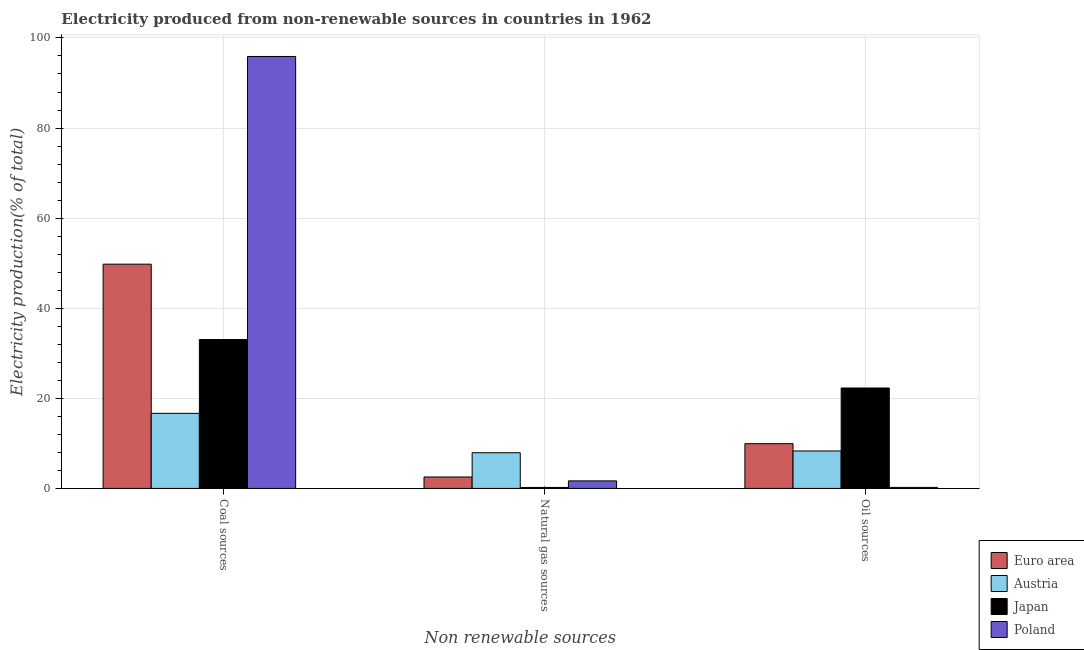How many groups of bars are there?
Your answer should be very brief. 3. Are the number of bars on each tick of the X-axis equal?
Offer a very short reply. Yes. How many bars are there on the 1st tick from the left?
Offer a very short reply. 4. What is the label of the 3rd group of bars from the left?
Your answer should be compact. Oil sources. What is the percentage of electricity produced by oil sources in Japan?
Offer a terse response. 22.29. Across all countries, what is the maximum percentage of electricity produced by natural gas?
Make the answer very short. 7.92. Across all countries, what is the minimum percentage of electricity produced by coal?
Ensure brevity in your answer.  16.66. In which country was the percentage of electricity produced by coal minimum?
Your response must be concise. Austria. What is the total percentage of electricity produced by coal in the graph?
Keep it short and to the point. 195.38. What is the difference between the percentage of electricity produced by coal in Japan and that in Poland?
Give a very brief answer. -62.84. What is the difference between the percentage of electricity produced by coal in Austria and the percentage of electricity produced by oil sources in Euro area?
Your answer should be compact. 6.73. What is the average percentage of electricity produced by natural gas per country?
Provide a succinct answer. 3.09. What is the difference between the percentage of electricity produced by natural gas and percentage of electricity produced by coal in Poland?
Your response must be concise. -94.22. In how many countries, is the percentage of electricity produced by oil sources greater than 16 %?
Offer a very short reply. 1. What is the ratio of the percentage of electricity produced by coal in Euro area to that in Poland?
Make the answer very short. 0.52. Is the percentage of electricity produced by natural gas in Poland less than that in Japan?
Your response must be concise. No. What is the difference between the highest and the second highest percentage of electricity produced by coal?
Your answer should be compact. 46.11. What is the difference between the highest and the lowest percentage of electricity produced by natural gas?
Make the answer very short. 7.71. What does the 1st bar from the right in Oil sources represents?
Provide a succinct answer. Poland. Is it the case that in every country, the sum of the percentage of electricity produced by coal and percentage of electricity produced by natural gas is greater than the percentage of electricity produced by oil sources?
Give a very brief answer. Yes. Are the values on the major ticks of Y-axis written in scientific E-notation?
Ensure brevity in your answer.  No. Does the graph contain grids?
Ensure brevity in your answer.  Yes. How many legend labels are there?
Give a very brief answer. 4. What is the title of the graph?
Provide a short and direct response. Electricity produced from non-renewable sources in countries in 1962. What is the label or title of the X-axis?
Offer a terse response. Non renewable sources. What is the label or title of the Y-axis?
Provide a short and direct response. Electricity production(% of total). What is the Electricity production(% of total) of Euro area in Coal sources?
Keep it short and to the point. 49.78. What is the Electricity production(% of total) of Austria in Coal sources?
Your answer should be compact. 16.66. What is the Electricity production(% of total) of Japan in Coal sources?
Offer a terse response. 33.05. What is the Electricity production(% of total) in Poland in Coal sources?
Make the answer very short. 95.89. What is the Electricity production(% of total) in Euro area in Natural gas sources?
Offer a very short reply. 2.54. What is the Electricity production(% of total) in Austria in Natural gas sources?
Provide a succinct answer. 7.92. What is the Electricity production(% of total) in Japan in Natural gas sources?
Give a very brief answer. 0.21. What is the Electricity production(% of total) of Poland in Natural gas sources?
Give a very brief answer. 1.67. What is the Electricity production(% of total) of Euro area in Oil sources?
Give a very brief answer. 9.93. What is the Electricity production(% of total) of Austria in Oil sources?
Offer a very short reply. 8.31. What is the Electricity production(% of total) in Japan in Oil sources?
Your response must be concise. 22.29. What is the Electricity production(% of total) of Poland in Oil sources?
Your response must be concise. 0.23. Across all Non renewable sources, what is the maximum Electricity production(% of total) in Euro area?
Keep it short and to the point. 49.78. Across all Non renewable sources, what is the maximum Electricity production(% of total) of Austria?
Ensure brevity in your answer.  16.66. Across all Non renewable sources, what is the maximum Electricity production(% of total) of Japan?
Ensure brevity in your answer.  33.05. Across all Non renewable sources, what is the maximum Electricity production(% of total) of Poland?
Your answer should be compact. 95.89. Across all Non renewable sources, what is the minimum Electricity production(% of total) in Euro area?
Your answer should be compact. 2.54. Across all Non renewable sources, what is the minimum Electricity production(% of total) in Austria?
Provide a short and direct response. 7.92. Across all Non renewable sources, what is the minimum Electricity production(% of total) in Japan?
Provide a short and direct response. 0.21. Across all Non renewable sources, what is the minimum Electricity production(% of total) in Poland?
Your response must be concise. 0.23. What is the total Electricity production(% of total) in Euro area in the graph?
Your answer should be very brief. 62.25. What is the total Electricity production(% of total) in Austria in the graph?
Offer a very short reply. 32.9. What is the total Electricity production(% of total) in Japan in the graph?
Your answer should be very brief. 55.56. What is the total Electricity production(% of total) of Poland in the graph?
Give a very brief answer. 97.79. What is the difference between the Electricity production(% of total) in Euro area in Coal sources and that in Natural gas sources?
Your answer should be very brief. 47.24. What is the difference between the Electricity production(% of total) in Austria in Coal sources and that in Natural gas sources?
Keep it short and to the point. 8.74. What is the difference between the Electricity production(% of total) in Japan in Coal sources and that in Natural gas sources?
Give a very brief answer. 32.83. What is the difference between the Electricity production(% of total) of Poland in Coal sources and that in Natural gas sources?
Ensure brevity in your answer.  94.22. What is the difference between the Electricity production(% of total) of Euro area in Coal sources and that in Oil sources?
Your response must be concise. 39.85. What is the difference between the Electricity production(% of total) in Austria in Coal sources and that in Oil sources?
Give a very brief answer. 8.35. What is the difference between the Electricity production(% of total) of Japan in Coal sources and that in Oil sources?
Your answer should be very brief. 10.76. What is the difference between the Electricity production(% of total) in Poland in Coal sources and that in Oil sources?
Offer a very short reply. 95.66. What is the difference between the Electricity production(% of total) of Euro area in Natural gas sources and that in Oil sources?
Provide a short and direct response. -7.39. What is the difference between the Electricity production(% of total) in Austria in Natural gas sources and that in Oil sources?
Offer a terse response. -0.39. What is the difference between the Electricity production(% of total) in Japan in Natural gas sources and that in Oil sources?
Your answer should be compact. -22.08. What is the difference between the Electricity production(% of total) of Poland in Natural gas sources and that in Oil sources?
Provide a succinct answer. 1.45. What is the difference between the Electricity production(% of total) in Euro area in Coal sources and the Electricity production(% of total) in Austria in Natural gas sources?
Give a very brief answer. 41.86. What is the difference between the Electricity production(% of total) in Euro area in Coal sources and the Electricity production(% of total) in Japan in Natural gas sources?
Your answer should be very brief. 49.57. What is the difference between the Electricity production(% of total) in Euro area in Coal sources and the Electricity production(% of total) in Poland in Natural gas sources?
Your response must be concise. 48.11. What is the difference between the Electricity production(% of total) of Austria in Coal sources and the Electricity production(% of total) of Japan in Natural gas sources?
Provide a short and direct response. 16.45. What is the difference between the Electricity production(% of total) of Austria in Coal sources and the Electricity production(% of total) of Poland in Natural gas sources?
Your response must be concise. 14.99. What is the difference between the Electricity production(% of total) of Japan in Coal sources and the Electricity production(% of total) of Poland in Natural gas sources?
Give a very brief answer. 31.38. What is the difference between the Electricity production(% of total) of Euro area in Coal sources and the Electricity production(% of total) of Austria in Oil sources?
Keep it short and to the point. 41.47. What is the difference between the Electricity production(% of total) of Euro area in Coal sources and the Electricity production(% of total) of Japan in Oil sources?
Ensure brevity in your answer.  27.49. What is the difference between the Electricity production(% of total) of Euro area in Coal sources and the Electricity production(% of total) of Poland in Oil sources?
Provide a succinct answer. 49.56. What is the difference between the Electricity production(% of total) in Austria in Coal sources and the Electricity production(% of total) in Japan in Oil sources?
Give a very brief answer. -5.63. What is the difference between the Electricity production(% of total) of Austria in Coal sources and the Electricity production(% of total) of Poland in Oil sources?
Provide a short and direct response. 16.44. What is the difference between the Electricity production(% of total) of Japan in Coal sources and the Electricity production(% of total) of Poland in Oil sources?
Ensure brevity in your answer.  32.82. What is the difference between the Electricity production(% of total) in Euro area in Natural gas sources and the Electricity production(% of total) in Austria in Oil sources?
Make the answer very short. -5.77. What is the difference between the Electricity production(% of total) of Euro area in Natural gas sources and the Electricity production(% of total) of Japan in Oil sources?
Offer a very short reply. -19.75. What is the difference between the Electricity production(% of total) of Euro area in Natural gas sources and the Electricity production(% of total) of Poland in Oil sources?
Your response must be concise. 2.31. What is the difference between the Electricity production(% of total) of Austria in Natural gas sources and the Electricity production(% of total) of Japan in Oil sources?
Your answer should be very brief. -14.37. What is the difference between the Electricity production(% of total) in Austria in Natural gas sources and the Electricity production(% of total) in Poland in Oil sources?
Give a very brief answer. 7.7. What is the difference between the Electricity production(% of total) in Japan in Natural gas sources and the Electricity production(% of total) in Poland in Oil sources?
Provide a succinct answer. -0.01. What is the average Electricity production(% of total) in Euro area per Non renewable sources?
Your answer should be compact. 20.75. What is the average Electricity production(% of total) of Austria per Non renewable sources?
Your answer should be compact. 10.97. What is the average Electricity production(% of total) of Japan per Non renewable sources?
Offer a terse response. 18.52. What is the average Electricity production(% of total) in Poland per Non renewable sources?
Provide a succinct answer. 32.6. What is the difference between the Electricity production(% of total) in Euro area and Electricity production(% of total) in Austria in Coal sources?
Your response must be concise. 33.12. What is the difference between the Electricity production(% of total) of Euro area and Electricity production(% of total) of Japan in Coal sources?
Provide a succinct answer. 16.73. What is the difference between the Electricity production(% of total) in Euro area and Electricity production(% of total) in Poland in Coal sources?
Ensure brevity in your answer.  -46.11. What is the difference between the Electricity production(% of total) of Austria and Electricity production(% of total) of Japan in Coal sources?
Keep it short and to the point. -16.38. What is the difference between the Electricity production(% of total) in Austria and Electricity production(% of total) in Poland in Coal sources?
Offer a very short reply. -79.22. What is the difference between the Electricity production(% of total) in Japan and Electricity production(% of total) in Poland in Coal sources?
Make the answer very short. -62.84. What is the difference between the Electricity production(% of total) of Euro area and Electricity production(% of total) of Austria in Natural gas sources?
Provide a short and direct response. -5.38. What is the difference between the Electricity production(% of total) of Euro area and Electricity production(% of total) of Japan in Natural gas sources?
Make the answer very short. 2.33. What is the difference between the Electricity production(% of total) in Euro area and Electricity production(% of total) in Poland in Natural gas sources?
Give a very brief answer. 0.87. What is the difference between the Electricity production(% of total) of Austria and Electricity production(% of total) of Japan in Natural gas sources?
Your answer should be compact. 7.71. What is the difference between the Electricity production(% of total) in Austria and Electricity production(% of total) in Poland in Natural gas sources?
Offer a terse response. 6.25. What is the difference between the Electricity production(% of total) in Japan and Electricity production(% of total) in Poland in Natural gas sources?
Your answer should be very brief. -1.46. What is the difference between the Electricity production(% of total) in Euro area and Electricity production(% of total) in Austria in Oil sources?
Offer a terse response. 1.62. What is the difference between the Electricity production(% of total) of Euro area and Electricity production(% of total) of Japan in Oil sources?
Give a very brief answer. -12.36. What is the difference between the Electricity production(% of total) in Euro area and Electricity production(% of total) in Poland in Oil sources?
Your answer should be very brief. 9.71. What is the difference between the Electricity production(% of total) in Austria and Electricity production(% of total) in Japan in Oil sources?
Offer a terse response. -13.98. What is the difference between the Electricity production(% of total) in Austria and Electricity production(% of total) in Poland in Oil sources?
Offer a terse response. 8.09. What is the difference between the Electricity production(% of total) of Japan and Electricity production(% of total) of Poland in Oil sources?
Give a very brief answer. 22.07. What is the ratio of the Electricity production(% of total) of Euro area in Coal sources to that in Natural gas sources?
Offer a terse response. 19.6. What is the ratio of the Electricity production(% of total) of Austria in Coal sources to that in Natural gas sources?
Your answer should be very brief. 2.1. What is the ratio of the Electricity production(% of total) in Japan in Coal sources to that in Natural gas sources?
Give a very brief answer. 154.67. What is the ratio of the Electricity production(% of total) of Poland in Coal sources to that in Natural gas sources?
Make the answer very short. 57.38. What is the ratio of the Electricity production(% of total) in Euro area in Coal sources to that in Oil sources?
Make the answer very short. 5.01. What is the ratio of the Electricity production(% of total) in Austria in Coal sources to that in Oil sources?
Your answer should be compact. 2. What is the ratio of the Electricity production(% of total) in Japan in Coal sources to that in Oil sources?
Offer a terse response. 1.48. What is the ratio of the Electricity production(% of total) of Poland in Coal sources to that in Oil sources?
Make the answer very short. 423.88. What is the ratio of the Electricity production(% of total) of Euro area in Natural gas sources to that in Oil sources?
Provide a succinct answer. 0.26. What is the ratio of the Electricity production(% of total) in Austria in Natural gas sources to that in Oil sources?
Offer a terse response. 0.95. What is the ratio of the Electricity production(% of total) of Japan in Natural gas sources to that in Oil sources?
Give a very brief answer. 0.01. What is the ratio of the Electricity production(% of total) of Poland in Natural gas sources to that in Oil sources?
Your response must be concise. 7.39. What is the difference between the highest and the second highest Electricity production(% of total) of Euro area?
Keep it short and to the point. 39.85. What is the difference between the highest and the second highest Electricity production(% of total) of Austria?
Provide a succinct answer. 8.35. What is the difference between the highest and the second highest Electricity production(% of total) in Japan?
Keep it short and to the point. 10.76. What is the difference between the highest and the second highest Electricity production(% of total) in Poland?
Keep it short and to the point. 94.22. What is the difference between the highest and the lowest Electricity production(% of total) of Euro area?
Give a very brief answer. 47.24. What is the difference between the highest and the lowest Electricity production(% of total) of Austria?
Ensure brevity in your answer.  8.74. What is the difference between the highest and the lowest Electricity production(% of total) in Japan?
Provide a succinct answer. 32.83. What is the difference between the highest and the lowest Electricity production(% of total) in Poland?
Your answer should be very brief. 95.66. 